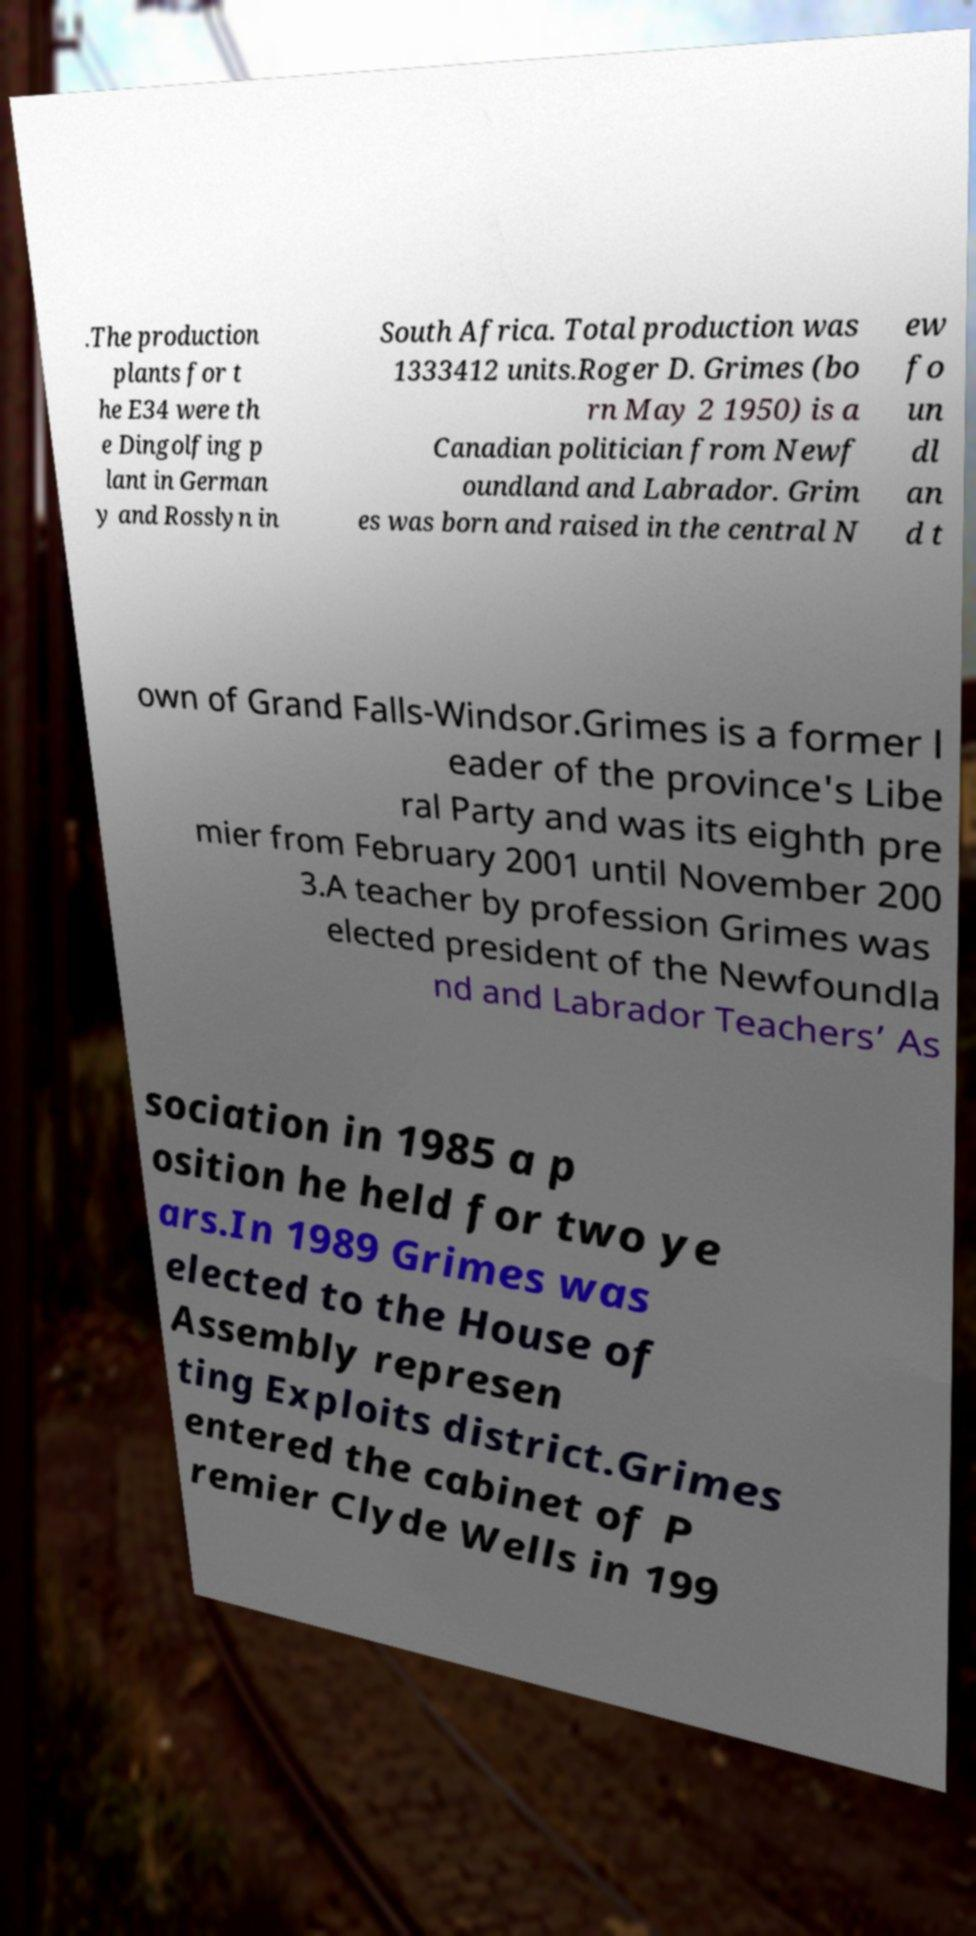Please identify and transcribe the text found in this image. .The production plants for t he E34 were th e Dingolfing p lant in German y and Rosslyn in South Africa. Total production was 1333412 units.Roger D. Grimes (bo rn May 2 1950) is a Canadian politician from Newf oundland and Labrador. Grim es was born and raised in the central N ew fo un dl an d t own of Grand Falls-Windsor.Grimes is a former l eader of the province's Libe ral Party and was its eighth pre mier from February 2001 until November 200 3.A teacher by profession Grimes was elected president of the Newfoundla nd and Labrador Teachers’ As sociation in 1985 a p osition he held for two ye ars.In 1989 Grimes was elected to the House of Assembly represen ting Exploits district.Grimes entered the cabinet of P remier Clyde Wells in 199 